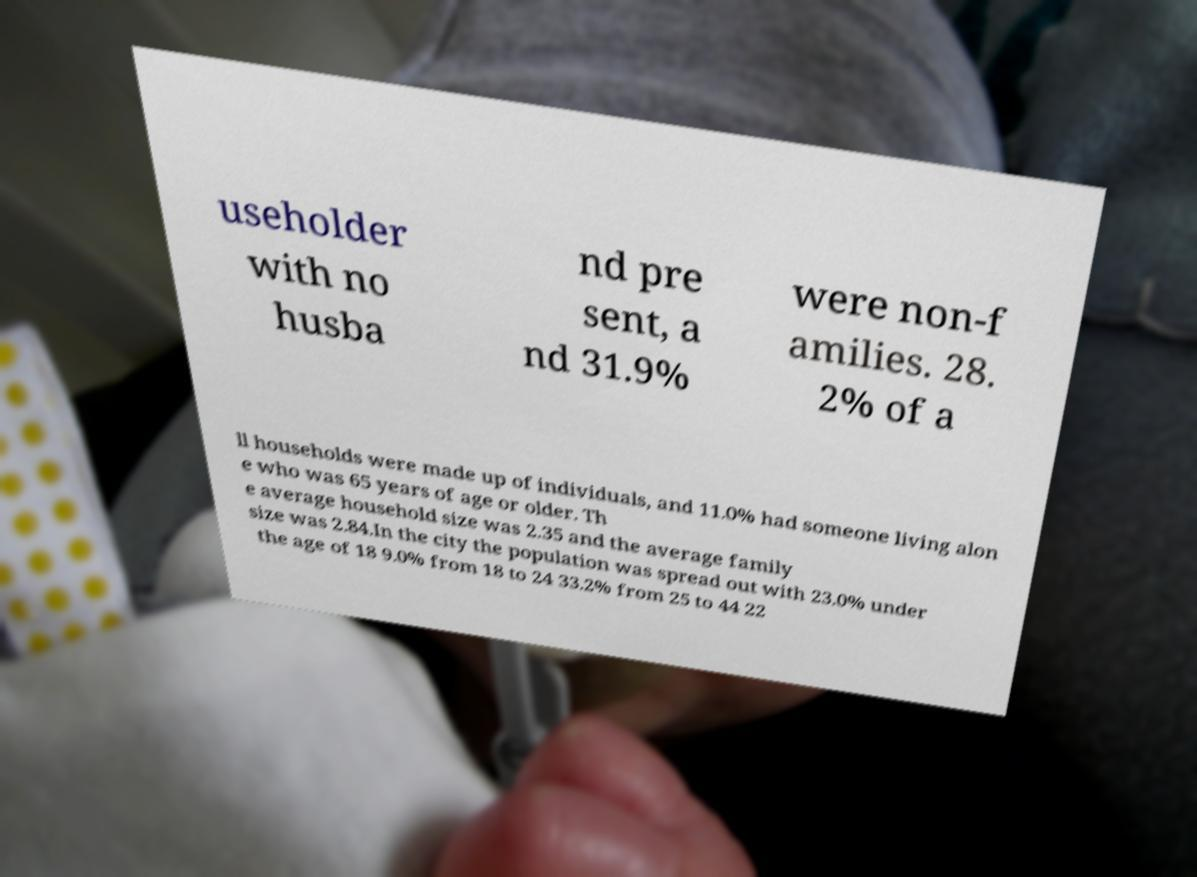For documentation purposes, I need the text within this image transcribed. Could you provide that? useholder with no husba nd pre sent, a nd 31.9% were non-f amilies. 28. 2% of a ll households were made up of individuals, and 11.0% had someone living alon e who was 65 years of age or older. Th e average household size was 2.35 and the average family size was 2.84.In the city the population was spread out with 23.0% under the age of 18 9.0% from 18 to 24 33.2% from 25 to 44 22 